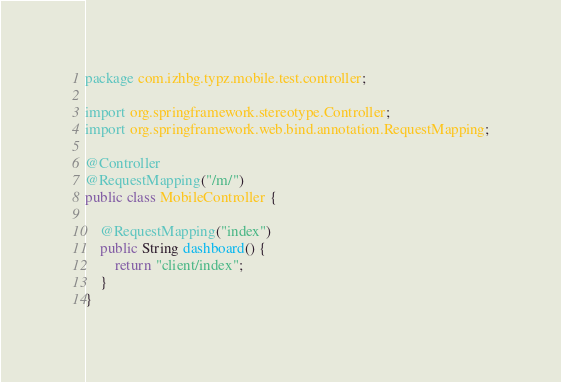Convert code to text. <code><loc_0><loc_0><loc_500><loc_500><_Java_>package com.izhbg.typz.mobile.test.controller;

import org.springframework.stereotype.Controller;
import org.springframework.web.bind.annotation.RequestMapping;

@Controller
@RequestMapping("/m/")
public class MobileController {
	
	@RequestMapping("index")
    public String dashboard() {
        return "client/index";
    }
}
</code> 